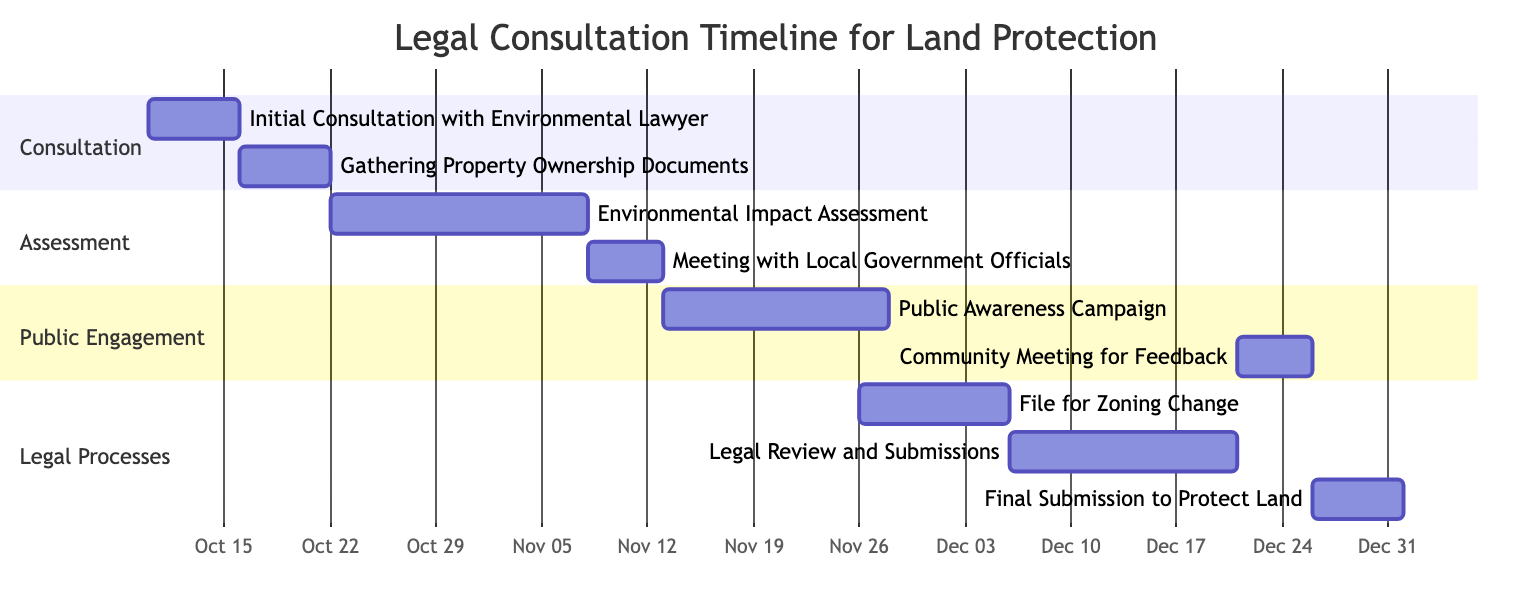What is the duration of the "Initial Consultation with Environmental Lawyer"? The task "Initial Consultation with Environmental Lawyer" starts on October 10, 2023, and ends on October 15, 2023. By counting the days from start to end, it lasts for 6 days.
Answer: 6 days Which task follows the "Environmental Impact Assessment"? After the "Environmental Impact Assessment", which ends on November 5, 2023, the next task according to the dependencies is "Meeting with Local Government Officials" that starts on November 6, 2023.
Answer: Meeting with Local Government Officials How many tasks require the completion of "Environmental Impact Assessment" before they can begin? Examining the dependencies, "Meeting with Local Government Officials" and "File for Zoning Change" both depend on the completion of "Environmental Impact Assessment". Therefore, there are 2 tasks that require its completion.
Answer: 2 tasks What is the earliest date on which the "Community Meeting for Feedback" starts? The "Community Meeting for Feedback" has a start date of December 21, 2023, as it follows "Legal Review and Submissions”, which starts on December 6, 2023. Thus, December 21, 2023 is the earliest start date.
Answer: December 21, 2023 Which task has the latest end date in the diagram? By reviewing the end dates of all tasks, "Final Submission to Protect Land" is the last task that ends on December 31, 2023. This makes it the task with the latest end date in the diagram.
Answer: December 31, 2023 What is the total number of tasks shown in the timeline? Counting all the tasks outlined in the diagram, there are a total of 9 distinct tasks including the initial consultation, assessment, public engagement, and legal processes.
Answer: 9 tasks Which task begins directly after the "Gathering Property Ownership Documents"? The task that follows "Gathering Property Ownership Documents", which ends on October 20, 2023, is "Environmental Impact Assessment" starting on October 20, 2023. Both tasks share the same end and start date respectively.
Answer: Environmental Impact Assessment What is the time span of the "Public Awareness Campaign"? The "Public Awareness Campaign" starts on November 11, 2023, and ends on November 25, 2023. To calculate the span, we count the number of days between these two dates, which amounts to 15 days.
Answer: 15 days 